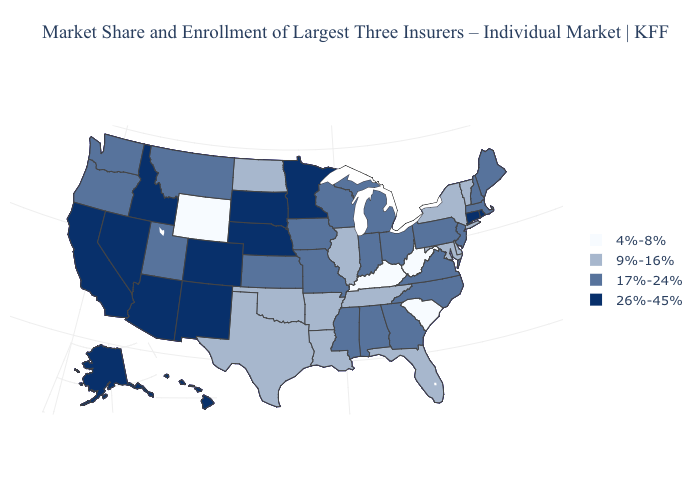What is the value of Connecticut?
Give a very brief answer. 26%-45%. What is the value of Indiana?
Give a very brief answer. 17%-24%. Name the states that have a value in the range 17%-24%?
Keep it brief. Alabama, Georgia, Indiana, Iowa, Kansas, Maine, Massachusetts, Michigan, Mississippi, Missouri, Montana, New Hampshire, New Jersey, North Carolina, Ohio, Oregon, Pennsylvania, Utah, Virginia, Washington, Wisconsin. Which states hav the highest value in the West?
Short answer required. Alaska, Arizona, California, Colorado, Hawaii, Idaho, Nevada, New Mexico. Name the states that have a value in the range 4%-8%?
Answer briefly. Kentucky, South Carolina, West Virginia, Wyoming. Which states have the lowest value in the MidWest?
Be succinct. Illinois, North Dakota. Does Nevada have a lower value than North Carolina?
Write a very short answer. No. Which states have the lowest value in the Northeast?
Short answer required. New York, Vermont. Which states have the lowest value in the USA?
Concise answer only. Kentucky, South Carolina, West Virginia, Wyoming. Name the states that have a value in the range 17%-24%?
Quick response, please. Alabama, Georgia, Indiana, Iowa, Kansas, Maine, Massachusetts, Michigan, Mississippi, Missouri, Montana, New Hampshire, New Jersey, North Carolina, Ohio, Oregon, Pennsylvania, Utah, Virginia, Washington, Wisconsin. What is the value of Alaska?
Answer briefly. 26%-45%. What is the highest value in the West ?
Be succinct. 26%-45%. What is the value of Michigan?
Keep it brief. 17%-24%. Does New Jersey have the lowest value in the USA?
Be succinct. No. Among the states that border Montana , does Idaho have the highest value?
Concise answer only. Yes. 